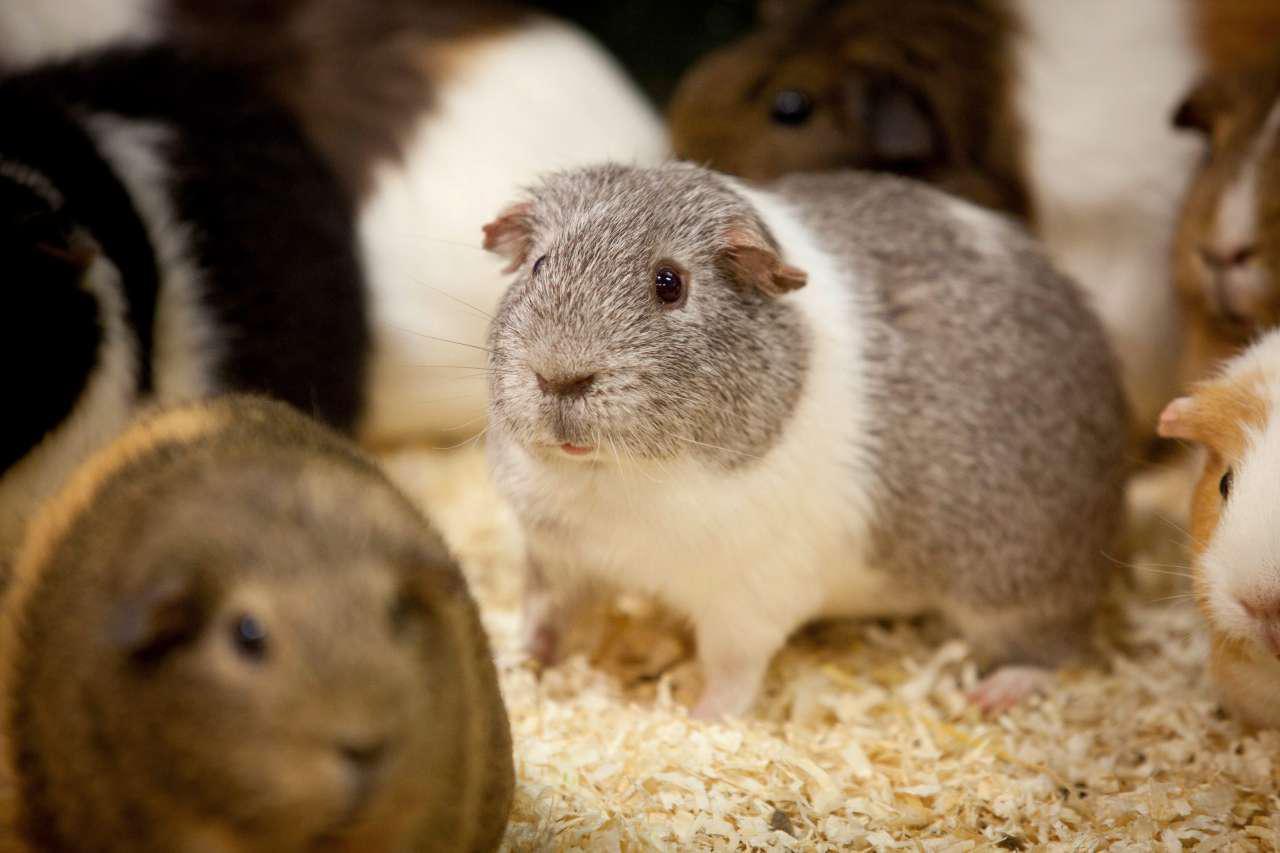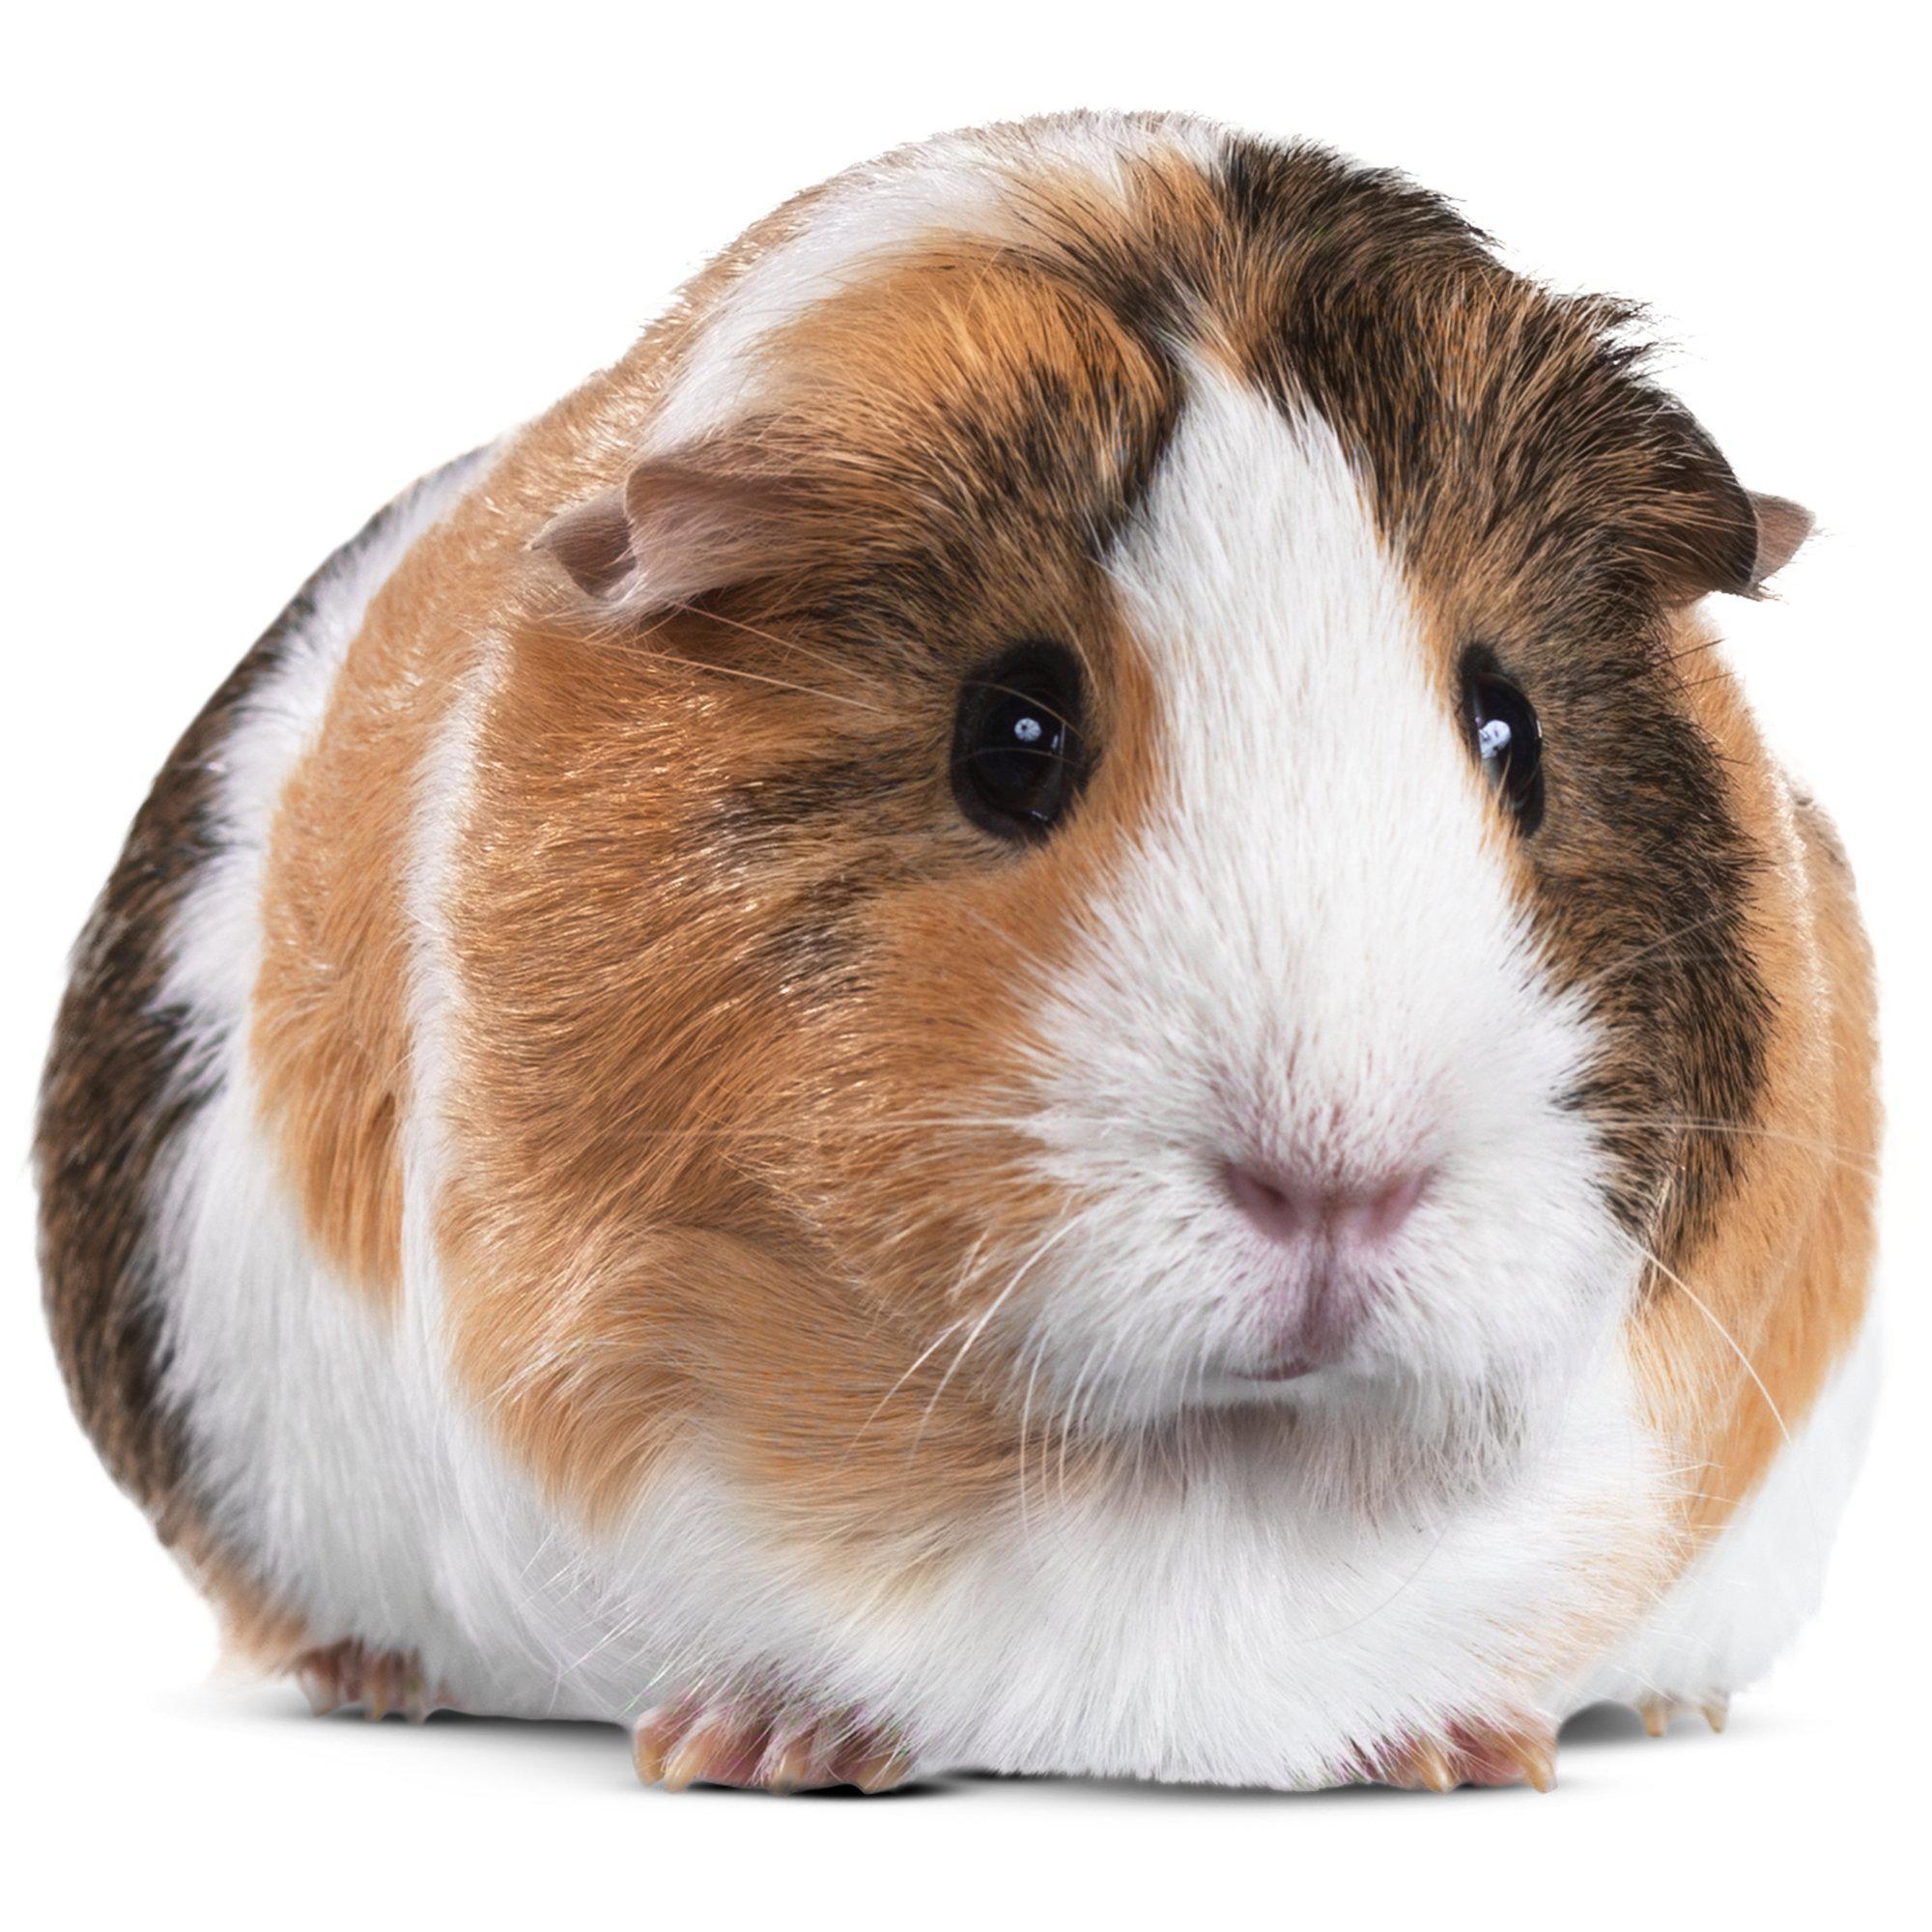The first image is the image on the left, the second image is the image on the right. Assess this claim about the two images: "The animal in the image on the right is on a plain white background". Correct or not? Answer yes or no. Yes. 